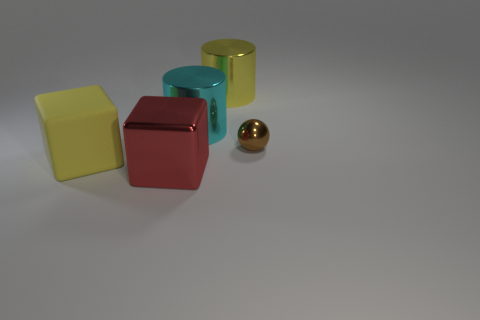Is the size of the metallic cube the same as the metallic thing on the right side of the big yellow metal object?
Provide a short and direct response. No. Are there any other things that have the same size as the metallic ball?
Provide a short and direct response. No. Is the number of small yellow matte cylinders greater than the number of tiny objects?
Ensure brevity in your answer.  No. What is the size of the block that is right of the big yellow object that is left of the cyan metallic thing?
Offer a very short reply. Large. What is the color of the other thing that is the same shape as the big cyan metal object?
Ensure brevity in your answer.  Yellow. What is the size of the brown metal ball?
Give a very brief answer. Small. What number of cylinders are brown objects or large red metallic objects?
Offer a very short reply. 0. What size is the red metal thing that is the same shape as the yellow rubber object?
Ensure brevity in your answer.  Large. What number of small purple matte cubes are there?
Keep it short and to the point. 0. Is the shape of the large yellow rubber thing the same as the yellow shiny thing that is to the left of the tiny brown sphere?
Make the answer very short. No. 